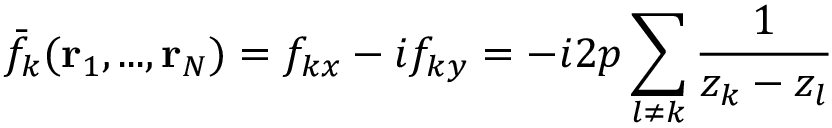<formula> <loc_0><loc_0><loc_500><loc_500>\bar { f } _ { k } ( { r } _ { 1 } , \dots , { r } _ { N } ) = f _ { k x } - i f _ { k y } = - i 2 p \sum _ { l \neq k } \frac { 1 } { z _ { k } - z _ { l } }</formula> 